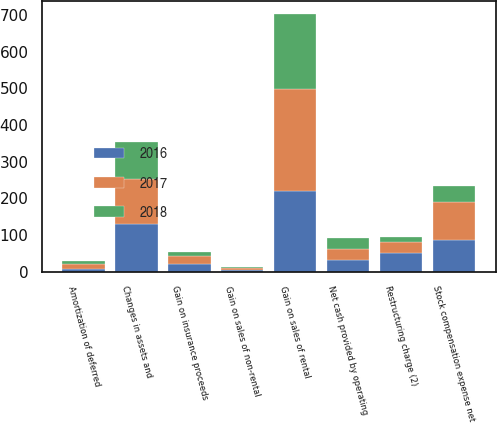Convert chart to OTSL. <chart><loc_0><loc_0><loc_500><loc_500><stacked_bar_chart><ecel><fcel>Net cash provided by operating<fcel>Amortization of deferred<fcel>Gain on sales of rental<fcel>Gain on sales of non-rental<fcel>Gain on insurance proceeds<fcel>Restructuring charge (2)<fcel>Stock compensation expense net<fcel>Changes in assets and<nl><fcel>2017<fcel>31<fcel>12<fcel>278<fcel>6<fcel>22<fcel>31<fcel>102<fcel>124<nl><fcel>2016<fcel>31<fcel>9<fcel>220<fcel>4<fcel>21<fcel>50<fcel>87<fcel>129<nl><fcel>2018<fcel>31<fcel>9<fcel>204<fcel>4<fcel>12<fcel>14<fcel>45<fcel>101<nl></chart> 